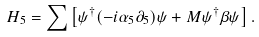<formula> <loc_0><loc_0><loc_500><loc_500>H _ { 5 } = \sum \left [ \psi ^ { \dag } ( - i \alpha _ { 5 } \partial _ { 5 } ) \psi + M \psi ^ { \dag } \beta \psi \right ] .</formula> 